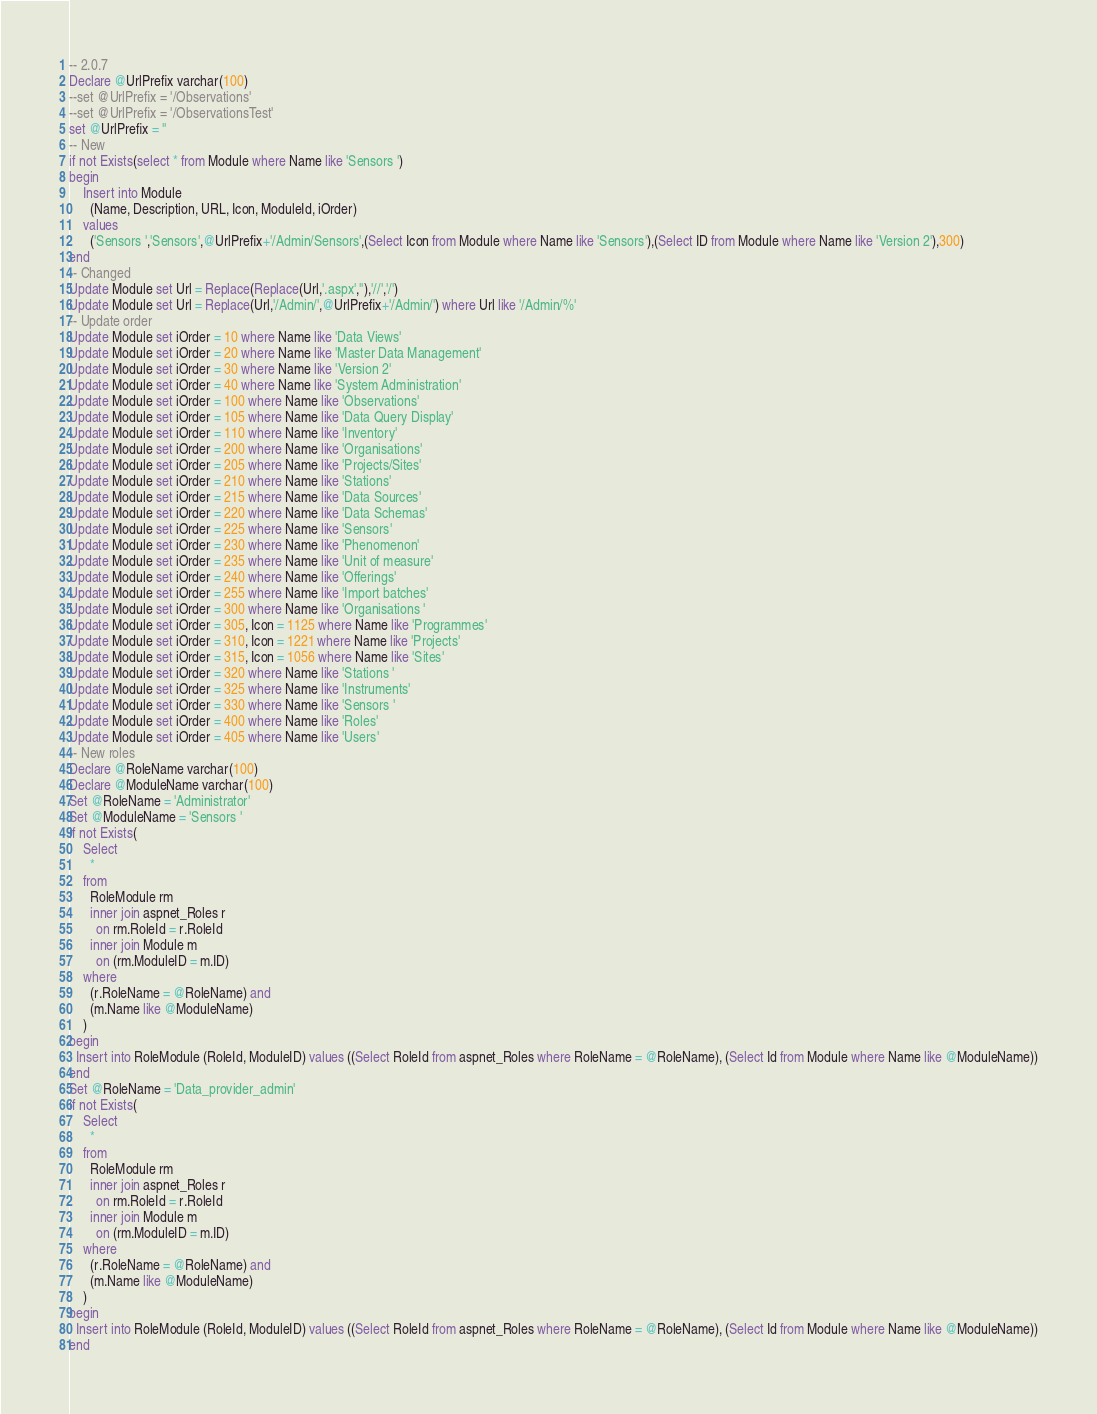Convert code to text. <code><loc_0><loc_0><loc_500><loc_500><_SQL_>-- 2.0.7
Declare @UrlPrefix varchar(100)
--set @UrlPrefix = '/Observations'
--set @UrlPrefix = '/ObservationsTest' 
set @UrlPrefix = ''
-- New
if not Exists(select * from Module where Name like 'Sensors ') 
begin
	Insert into Module
	  (Name, Description, URL, Icon, ModuleId, iOrder)
	values
	  ('Sensors ','Sensors',@UrlPrefix+'/Admin/Sensors',(Select Icon from Module where Name like 'Sensors'),(Select ID from Module where Name like 'Version 2'),300)
end
-- Changed
Update Module set Url = Replace(Replace(Url,'.aspx',''),'//','/')
Update Module set Url = Replace(Url,'/Admin/',@UrlPrefix+'/Admin/') where Url like '/Admin/%'
-- Update order
Update Module set iOrder = 10 where Name like 'Data Views'
Update Module set iOrder = 20 where Name like 'Master Data Management'
Update Module set iOrder = 30 where Name like 'Version 2'
Update Module set iOrder = 40 where Name like 'System Administration'
Update Module set iOrder = 100 where Name like 'Observations'
Update Module set iOrder = 105 where Name like 'Data Query Display'
Update Module set iOrder = 110 where Name like 'Inventory'
Update Module set iOrder = 200 where Name like 'Organisations'
Update Module set iOrder = 205 where Name like 'Projects/Sites'
Update Module set iOrder = 210 where Name like 'Stations'
Update Module set iOrder = 215 where Name like 'Data Sources'
Update Module set iOrder = 220 where Name like 'Data Schemas'
Update Module set iOrder = 225 where Name like 'Sensors'
Update Module set iOrder = 230 where Name like 'Phenomenon'
Update Module set iOrder = 235 where Name like 'Unit of measure'
Update Module set iOrder = 240 where Name like 'Offerings'
Update Module set iOrder = 255 where Name like 'Import batches'
Update Module set iOrder = 300 where Name like 'Organisations '
Update Module set iOrder = 305, Icon = 1125 where Name like 'Programmes'
Update Module set iOrder = 310, Icon = 1221 where Name like 'Projects'
Update Module set iOrder = 315, Icon = 1056 where Name like 'Sites'
Update Module set iOrder = 320 where Name like 'Stations '
Update Module set iOrder = 325 where Name like 'Instruments'
Update Module set iOrder = 330 where Name like 'Sensors '
Update Module set iOrder = 400 where Name like 'Roles'
Update Module set iOrder = 405 where Name like 'Users'
-- New roles
Declare @RoleName varchar(100)
Declare @ModuleName varchar(100)
Set @RoleName = 'Administrator'
Set @ModuleName = 'Sensors '
if not Exists(
	Select 
	  * 
	from
	  RoleModule rm
	  inner join aspnet_Roles r
		on rm.RoleId = r.RoleId
	  inner join Module m
	    on (rm.ModuleID = m.ID)
	where 
	  (r.RoleName = @RoleName) and
	  (m.Name like @ModuleName)
	)
begin
  Insert into RoleModule (RoleId, ModuleID) values ((Select RoleId from aspnet_Roles where RoleName = @RoleName), (Select Id from Module where Name like @ModuleName))
end
Set @RoleName = 'Data_provider_admin'
if not Exists(
	Select 
	  * 
	from
	  RoleModule rm
	  inner join aspnet_Roles r
		on rm.RoleId = r.RoleId
	  inner join Module m
	    on (rm.ModuleID = m.ID)
	where 
	  (r.RoleName = @RoleName) and
	  (m.Name like @ModuleName)
	)
begin
  Insert into RoleModule (RoleId, ModuleID) values ((Select RoleId from aspnet_Roles where RoleName = @RoleName), (Select Id from Module where Name like @ModuleName))
end
</code> 